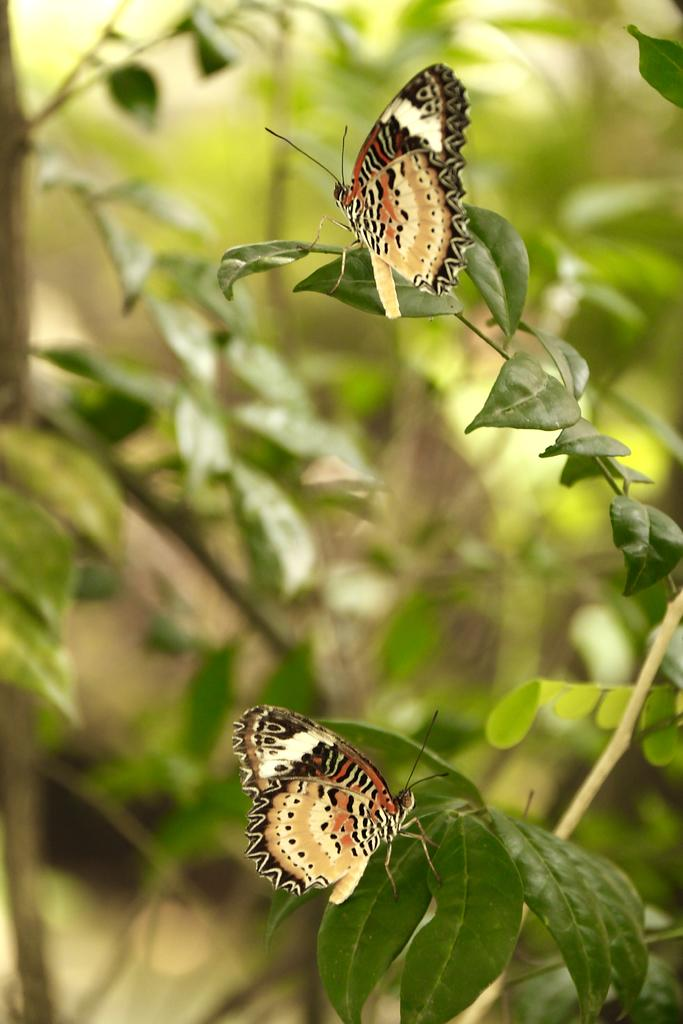What type of animals can be seen on the leaves in the foreground of the image? There are butterflies on the leaves in the foreground of the image. What can be seen in the background of the image? There is greenery in the background of the image. What type of soda is being poured onto the leaves in the image? There is no soda present in the image; it features butterflies on leaves and greenery in the background. 